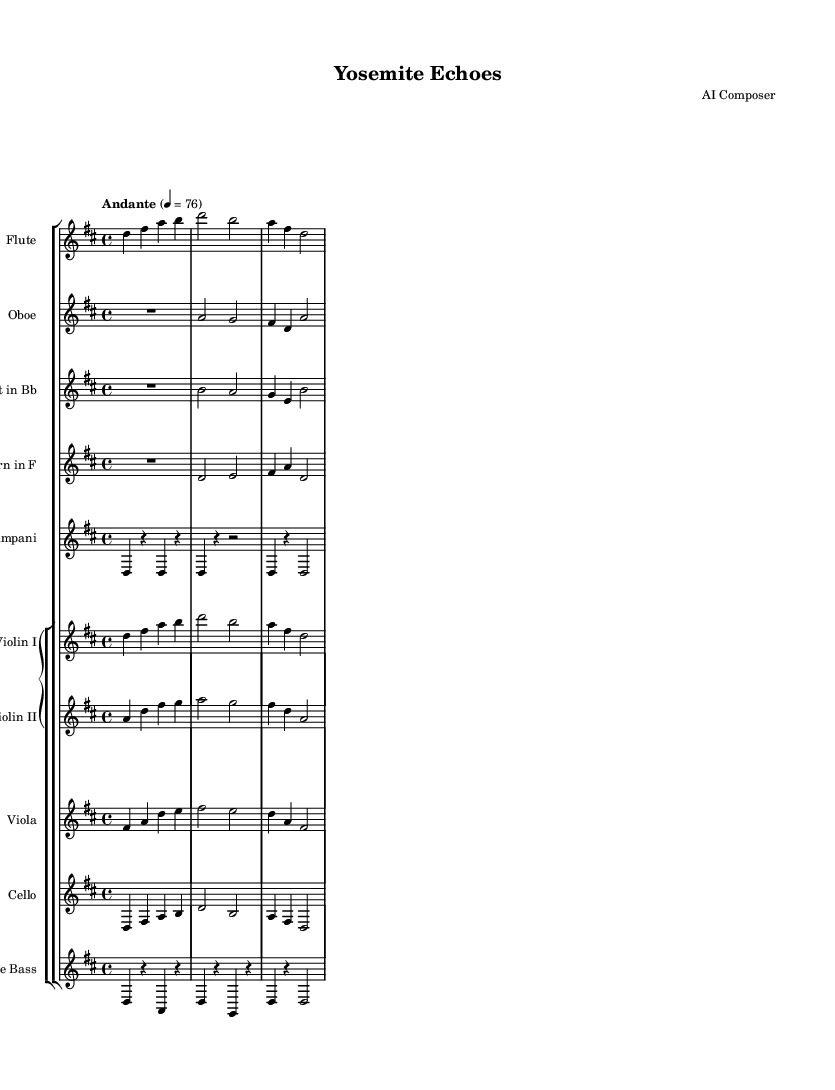What is the key signature of this music? The key signature shows two sharps, which indicates that the piece is in D major.
Answer: D major What is the time signature of this music? The time signature appears at the beginning of the score and is written as 4/4, meaning there are four beats per measure and a quarter note gets one beat.
Answer: 4/4 What is the tempo marking for this piece? The tempo is notated as "Andante" with a metronome mark of 76, indicating a moderate pace.
Answer: Andante, 76 How many measures are in the flute part? By counting the distinct groups of notes separated by vertical bar lines in the flute part, we find there are four measures total.
Answer: Four measures Which instruments are playing in this symphony? The score lists flute, oboe, clarinet, horn, timpani, two violins, viola, cello, and bass as the instruments in the orchestra.
Answer: Flute, oboe, clarinet, horn, timpani, violin I, violin II, viola, cello, bass What do the rests in the timpani part signify? The rests in the timpani part indicate that the timpani does not play during those beats, allowing silence before and after its notes, which contributes to the overall texture.
Answer: Silence How do the violin parts differ from each other? The first violin plays the primary melodic line and shares more rhythmic complexity with the flute, whereas the second violin provides harmonic support and a counter-melody that complements the first violin.
Answer: Different roles 